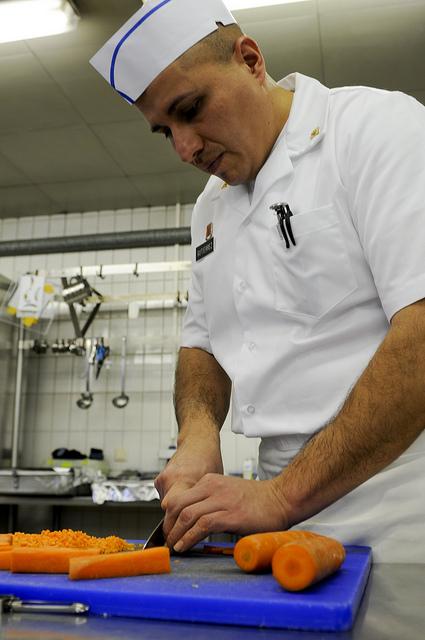What is the man doing?
Concise answer only. Chopping carrots. How hairy is this man?
Give a very brief answer. Very. Is the man wearing a hat?
Concise answer only. Yes. 